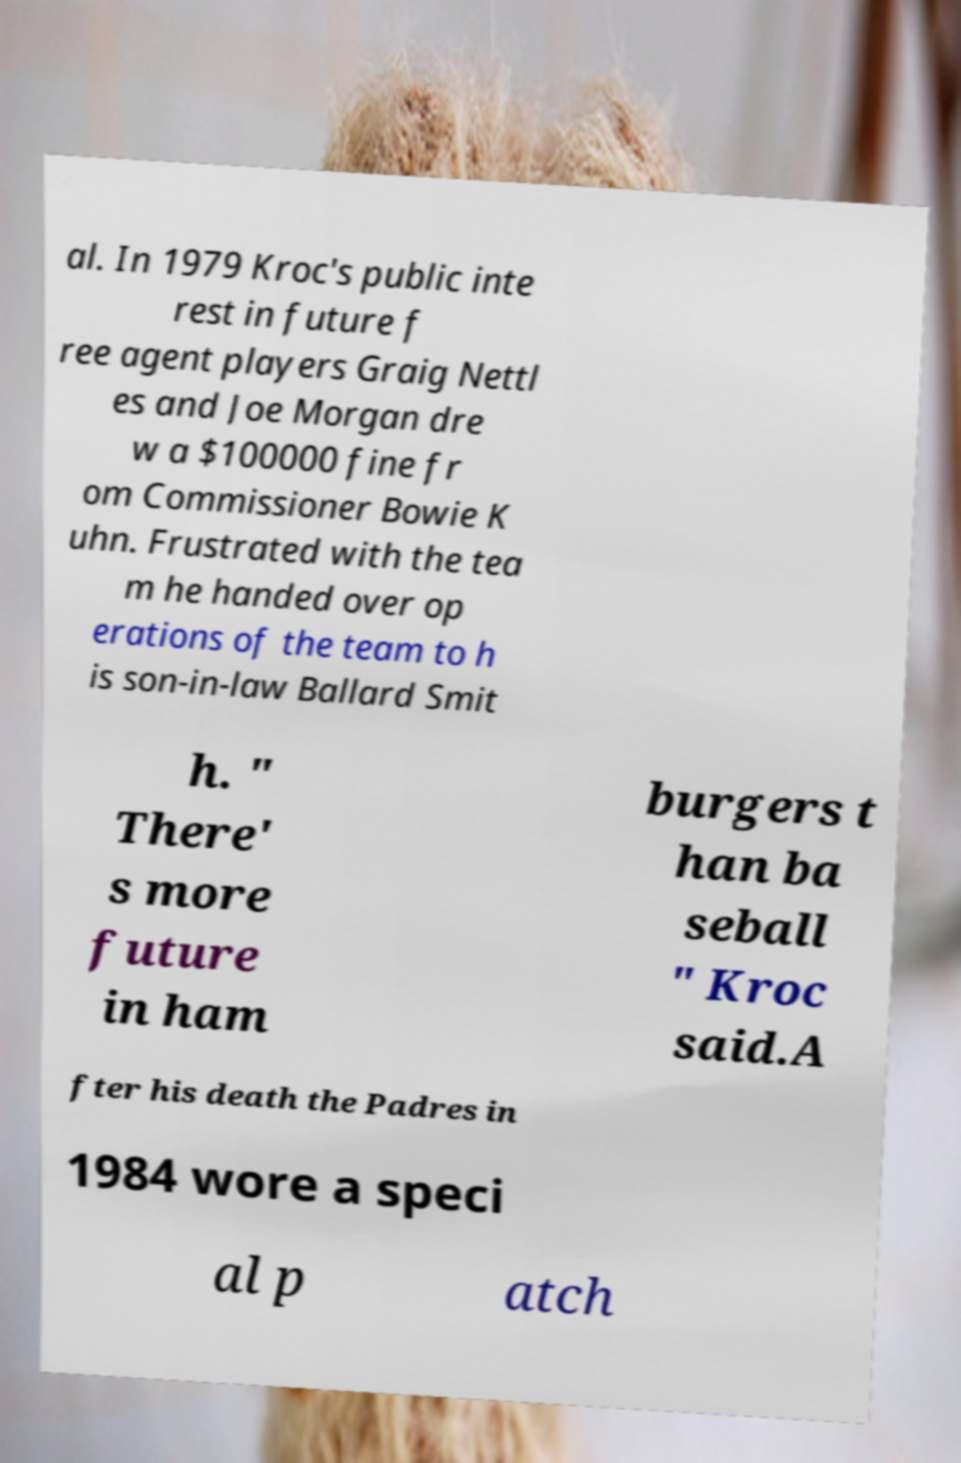There's text embedded in this image that I need extracted. Can you transcribe it verbatim? al. In 1979 Kroc's public inte rest in future f ree agent players Graig Nettl es and Joe Morgan dre w a $100000 fine fr om Commissioner Bowie K uhn. Frustrated with the tea m he handed over op erations of the team to h is son-in-law Ballard Smit h. " There' s more future in ham burgers t han ba seball " Kroc said.A fter his death the Padres in 1984 wore a speci al p atch 